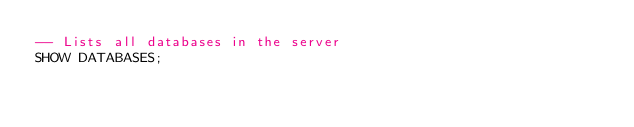<code> <loc_0><loc_0><loc_500><loc_500><_SQL_>-- Lists all databases in the server
SHOW DATABASES;
</code> 